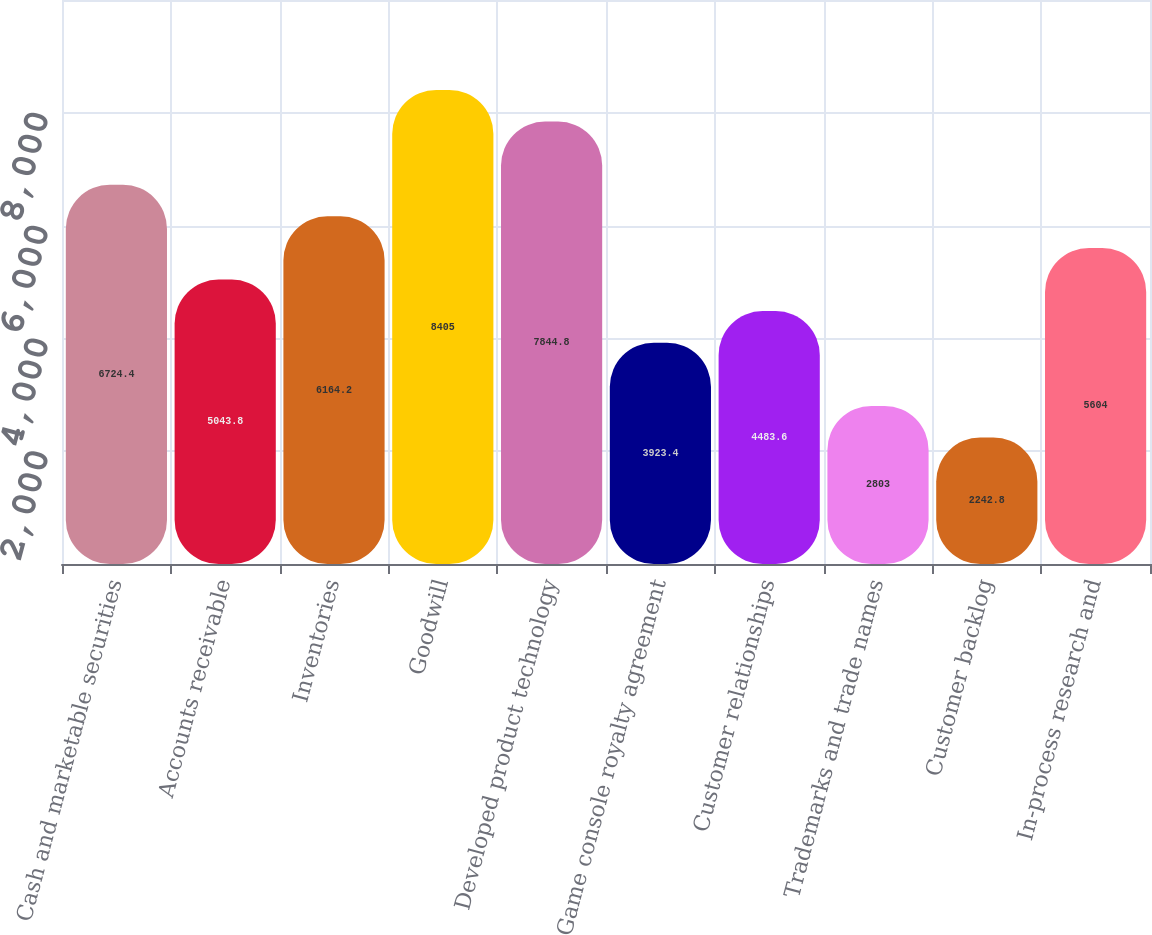Convert chart. <chart><loc_0><loc_0><loc_500><loc_500><bar_chart><fcel>Cash and marketable securities<fcel>Accounts receivable<fcel>Inventories<fcel>Goodwill<fcel>Developed product technology<fcel>Game console royalty agreement<fcel>Customer relationships<fcel>Trademarks and trade names<fcel>Customer backlog<fcel>In-process research and<nl><fcel>6724.4<fcel>5043.8<fcel>6164.2<fcel>8405<fcel>7844.8<fcel>3923.4<fcel>4483.6<fcel>2803<fcel>2242.8<fcel>5604<nl></chart> 